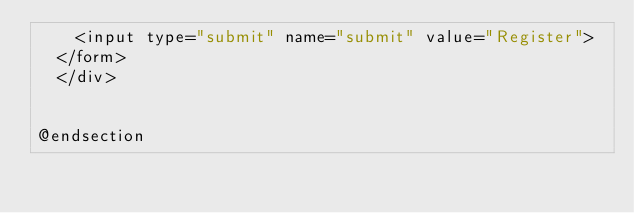Convert code to text. <code><loc_0><loc_0><loc_500><loc_500><_PHP_>		<input type="submit" name="submit" value="Register">
	</form>	
	</div>


@endsection</code> 